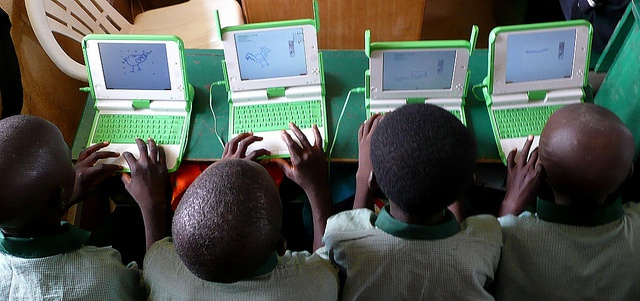Describe the objects in this image and their specific colors. I can see people in gray, black, and darkgray tones, people in gray and black tones, people in gray, black, and darkgray tones, people in gray, black, lightblue, and darkgray tones, and laptop in gray, lightgray, lightblue, and lightgreen tones in this image. 